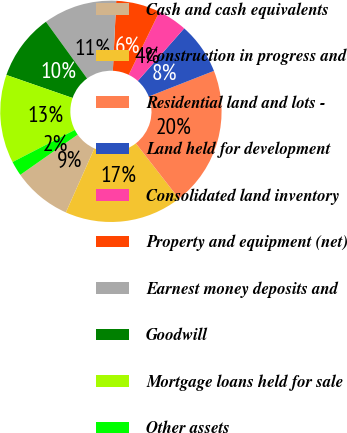Convert chart. <chart><loc_0><loc_0><loc_500><loc_500><pie_chart><fcel>Cash and cash equivalents<fcel>Construction in progress and<fcel>Residential land and lots -<fcel>Land held for development<fcel>Consolidated land inventory<fcel>Property and equipment (net)<fcel>Earnest money deposits and<fcel>Goodwill<fcel>Mortgage loans held for sale<fcel>Other assets<nl><fcel>8.6%<fcel>17.2%<fcel>20.42%<fcel>7.53%<fcel>4.3%<fcel>6.45%<fcel>10.75%<fcel>9.68%<fcel>12.9%<fcel>2.15%<nl></chart> 